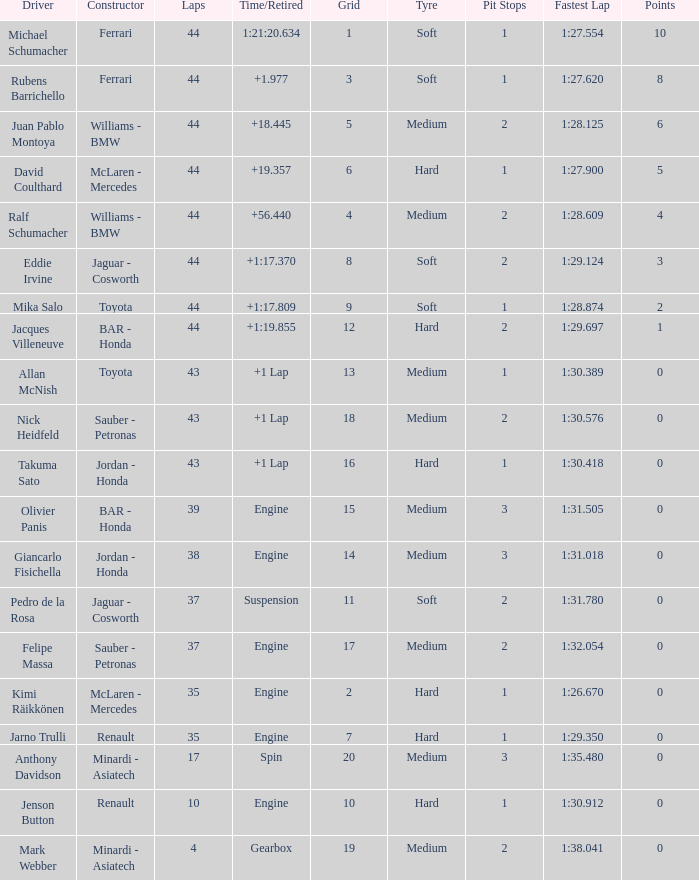What was the retired time on someone who had 43 laps on a grip of 18? +1 Lap. 